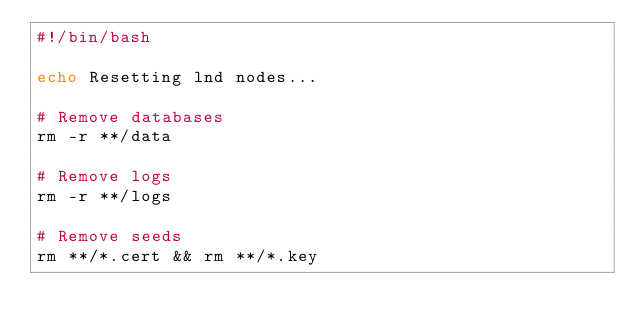Convert code to text. <code><loc_0><loc_0><loc_500><loc_500><_Bash_>#!/bin/bash

echo Resetting lnd nodes...

# Remove databases
rm -r **/data

# Remove logs
rm -r **/logs

# Remove seeds
rm **/*.cert && rm **/*.key
</code> 